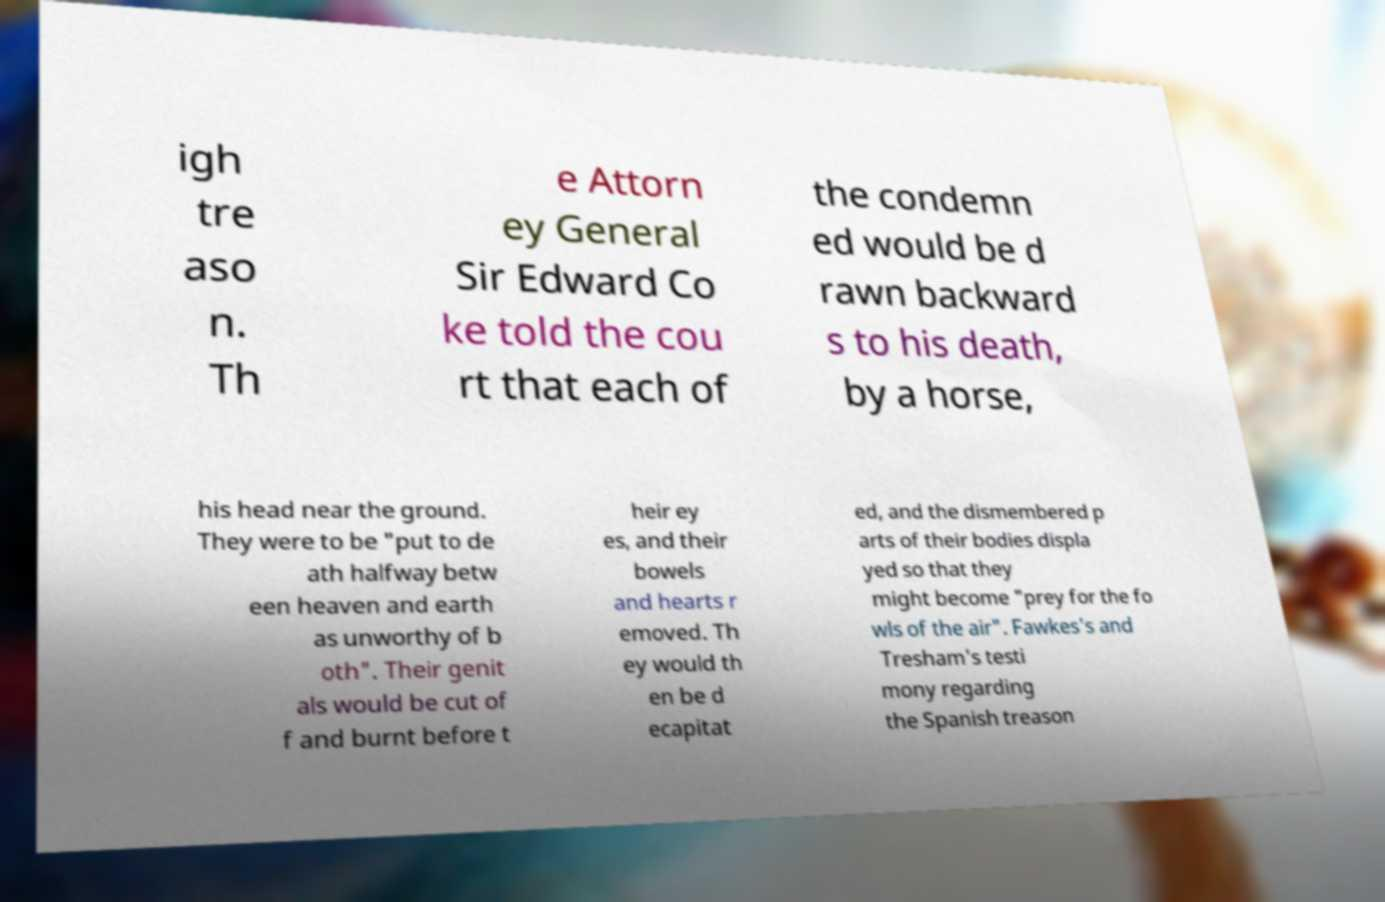Can you accurately transcribe the text from the provided image for me? igh tre aso n. Th e Attorn ey General Sir Edward Co ke told the cou rt that each of the condemn ed would be d rawn backward s to his death, by a horse, his head near the ground. They were to be "put to de ath halfway betw een heaven and earth as unworthy of b oth". Their genit als would be cut of f and burnt before t heir ey es, and their bowels and hearts r emoved. Th ey would th en be d ecapitat ed, and the dismembered p arts of their bodies displa yed so that they might become "prey for the fo wls of the air". Fawkes's and Tresham's testi mony regarding the Spanish treason 